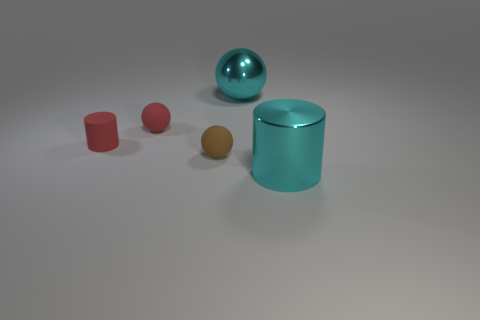Add 5 metal balls. How many objects exist? 10 Subtract all spheres. How many objects are left? 2 Subtract 0 purple cylinders. How many objects are left? 5 Subtract all big purple cylinders. Subtract all matte balls. How many objects are left? 3 Add 2 tiny brown things. How many tiny brown things are left? 3 Add 5 red matte spheres. How many red matte spheres exist? 6 